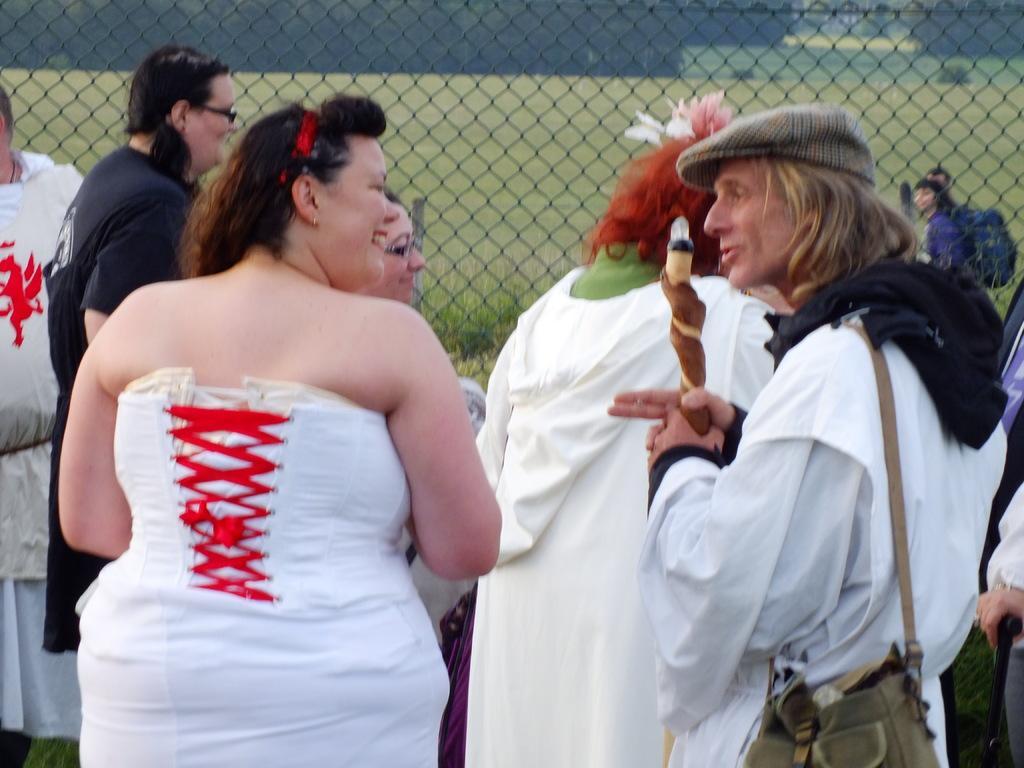Could you give a brief overview of what you see in this image? In this image there are group of persons standing, there is a person truncated towards the right of the image, there are person truncated towards the bottom of the image, there is a person truncated towards the left of the image, there is a person holding an object, the person is wearing a bag, he is talking, there is a fencing truncated towards the top of the image, there is the grass, there are plants, there are trees truncated towards the top of the image. 